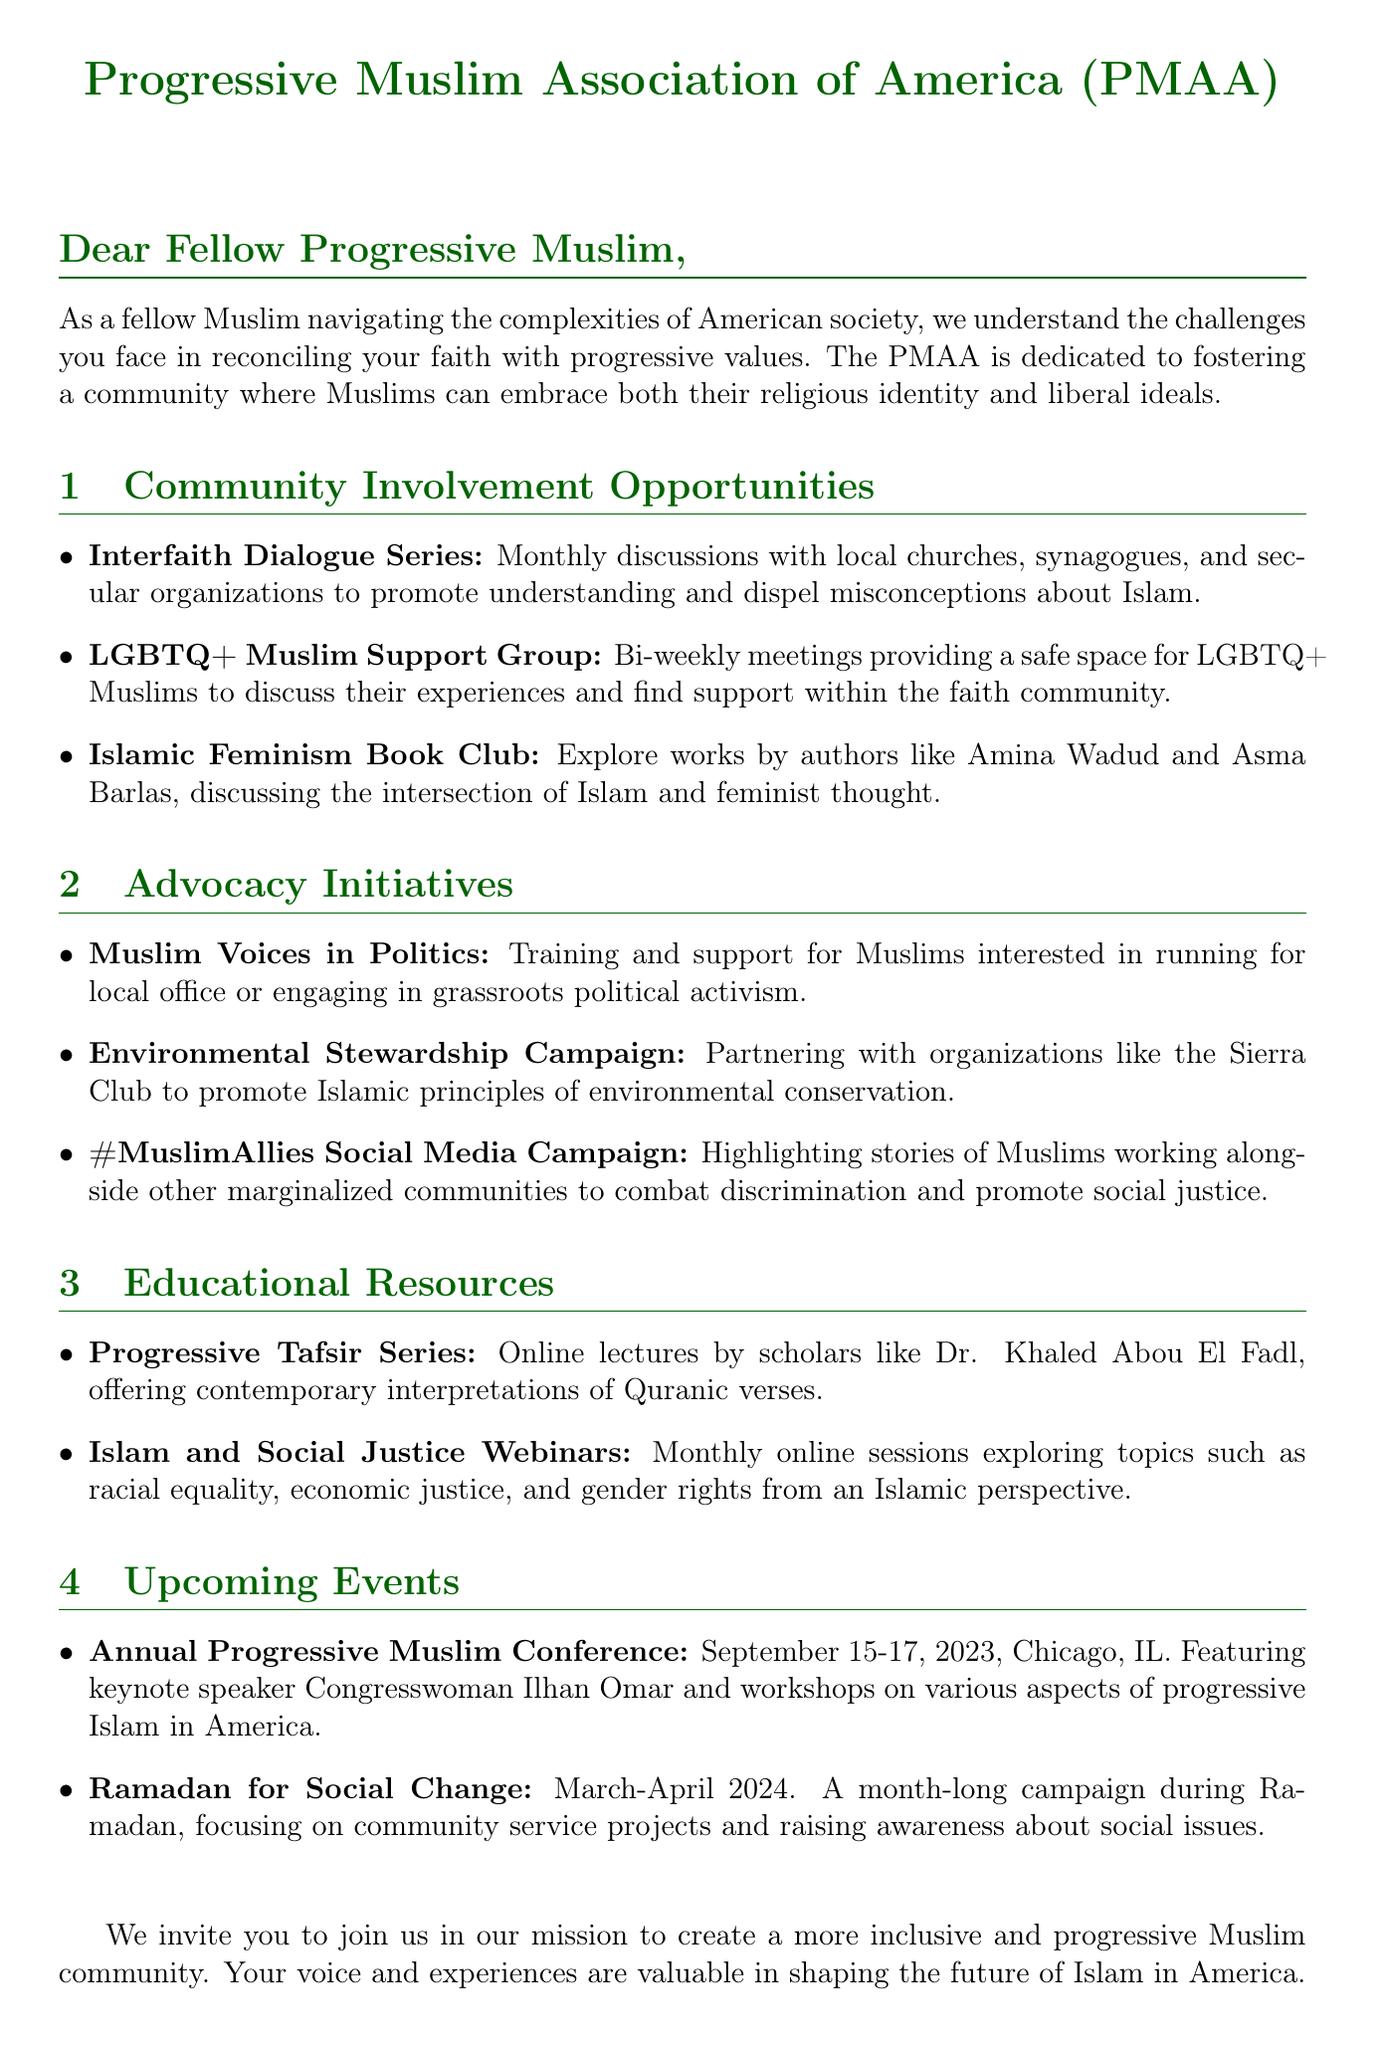What is the name of the organization? The document specifies that the organization is the "Progressive Muslim Association of America (PMAA)."
Answer: Progressive Muslim Association of America (PMAA) What is the name of the LGBTQ+ group? The document mentions a support group specifically for LGBTQ+ Muslims called the "LGBTQ+ Muslim Support Group."
Answer: LGBTQ+ Muslim Support Group When is the Annual Progressive Muslim Conference scheduled? The document states that the Annual Progressive Muslim Conference will be held on "September 15-17, 2023."
Answer: September 15-17, 2023 What kind of resources are provided in the "Educational Resources" section? The document details two educational resources: the "Progressive Tafsir Series" and "Islam and Social Justice Webinars."
Answer: Progressive Tafsir Series, Islam and Social Justice Webinars Which prominent speaker is featured at the conference? The document highlights that Congresswoman Ilhan Omar is the keynote speaker at the conference.
Answer: Congresswoman Ilhan Omar What is the focus of the Environmental Stewardship Campaign? The document explains that the campaign focuses on promoting Islamic principles of environmental conservation.
Answer: Islamic principles of environmental conservation How often do the Interfaith Dialogue Series occur? The document indicates that the Interfaith Dialogue Series occurs "monthly."
Answer: monthly What is the purpose of the #MuslimAllies Social Media Campaign? The document outlines that this campaign aims to highlight stories of Muslims working alongside marginalized communities.
Answer: Highlighting stories of Muslims working alongside marginalized communities What type of meetings does the Islamic Feminism Book Club hold? The document specifies that the Islamic Feminism Book Club hosts "discussions" of various works related to feminism and Islam.
Answer: discussions 